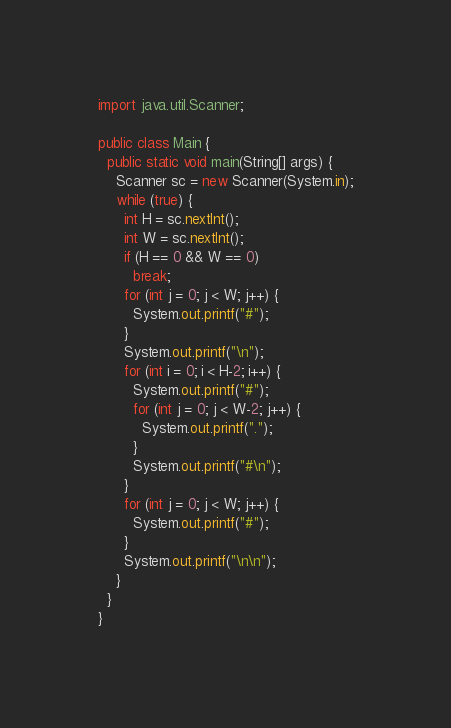Convert code to text. <code><loc_0><loc_0><loc_500><loc_500><_Java_>import java.util.Scanner;

public class Main {
  public static void main(String[] args) {
    Scanner sc = new Scanner(System.in);
    while (true) {
      int H = sc.nextInt();
      int W = sc.nextInt();
      if (H == 0 && W == 0)
        break;
      for (int j = 0; j < W; j++) {
        System.out.printf("#");
      }
      System.out.printf("\n");
      for (int i = 0; i < H-2; i++) {
        System.out.printf("#");
        for (int j = 0; j < W-2; j++) {
          System.out.printf(".");
        }
        System.out.printf("#\n");
      }
      for (int j = 0; j < W; j++) {
        System.out.printf("#");
      }
      System.out.printf("\n\n");
    }
  }
}</code> 